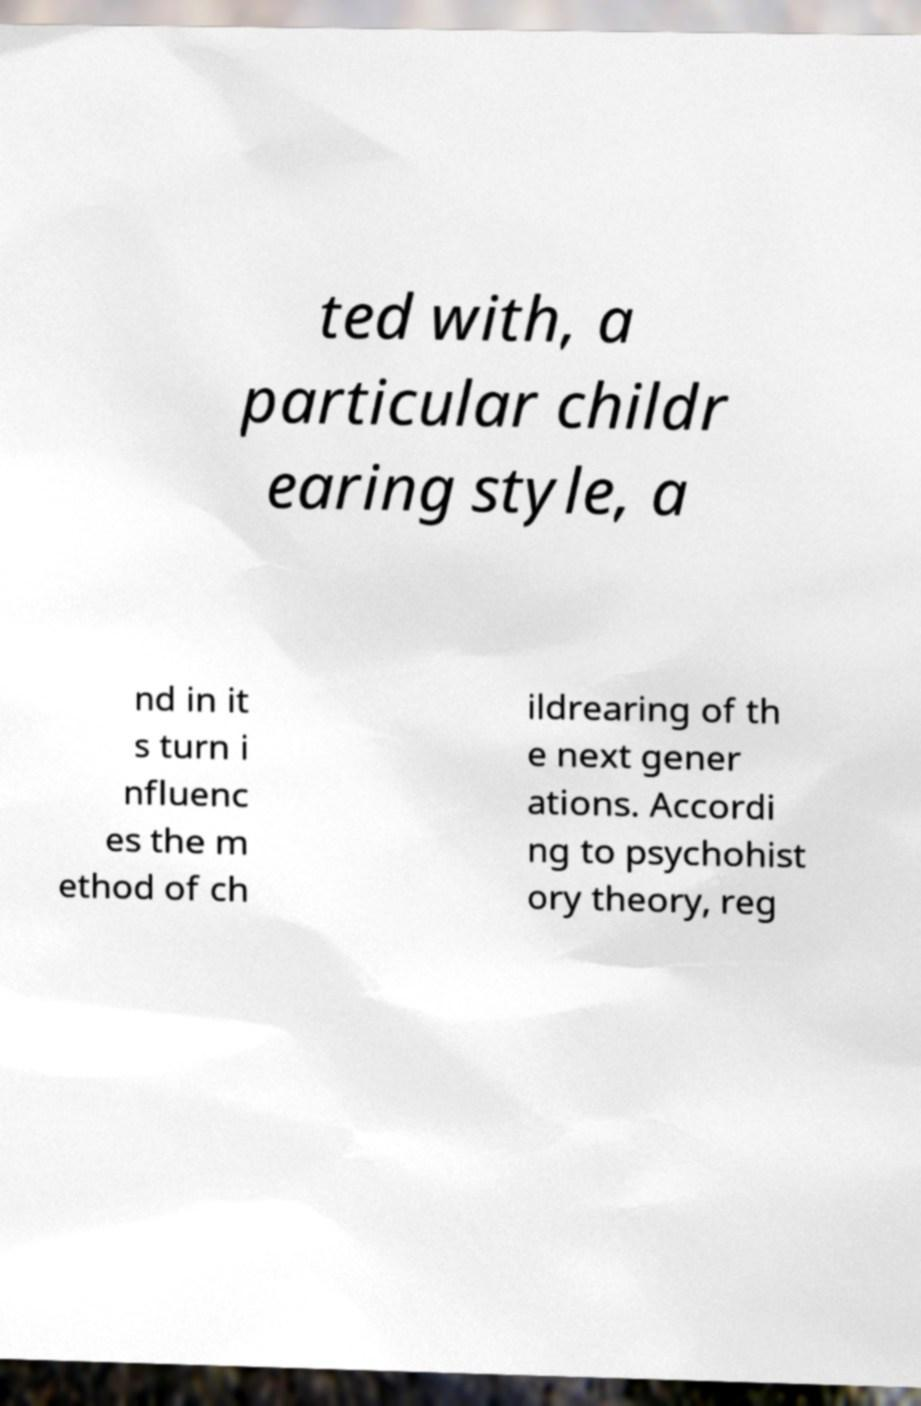Could you assist in decoding the text presented in this image and type it out clearly? ted with, a particular childr earing style, a nd in it s turn i nfluenc es the m ethod of ch ildrearing of th e next gener ations. Accordi ng to psychohist ory theory, reg 